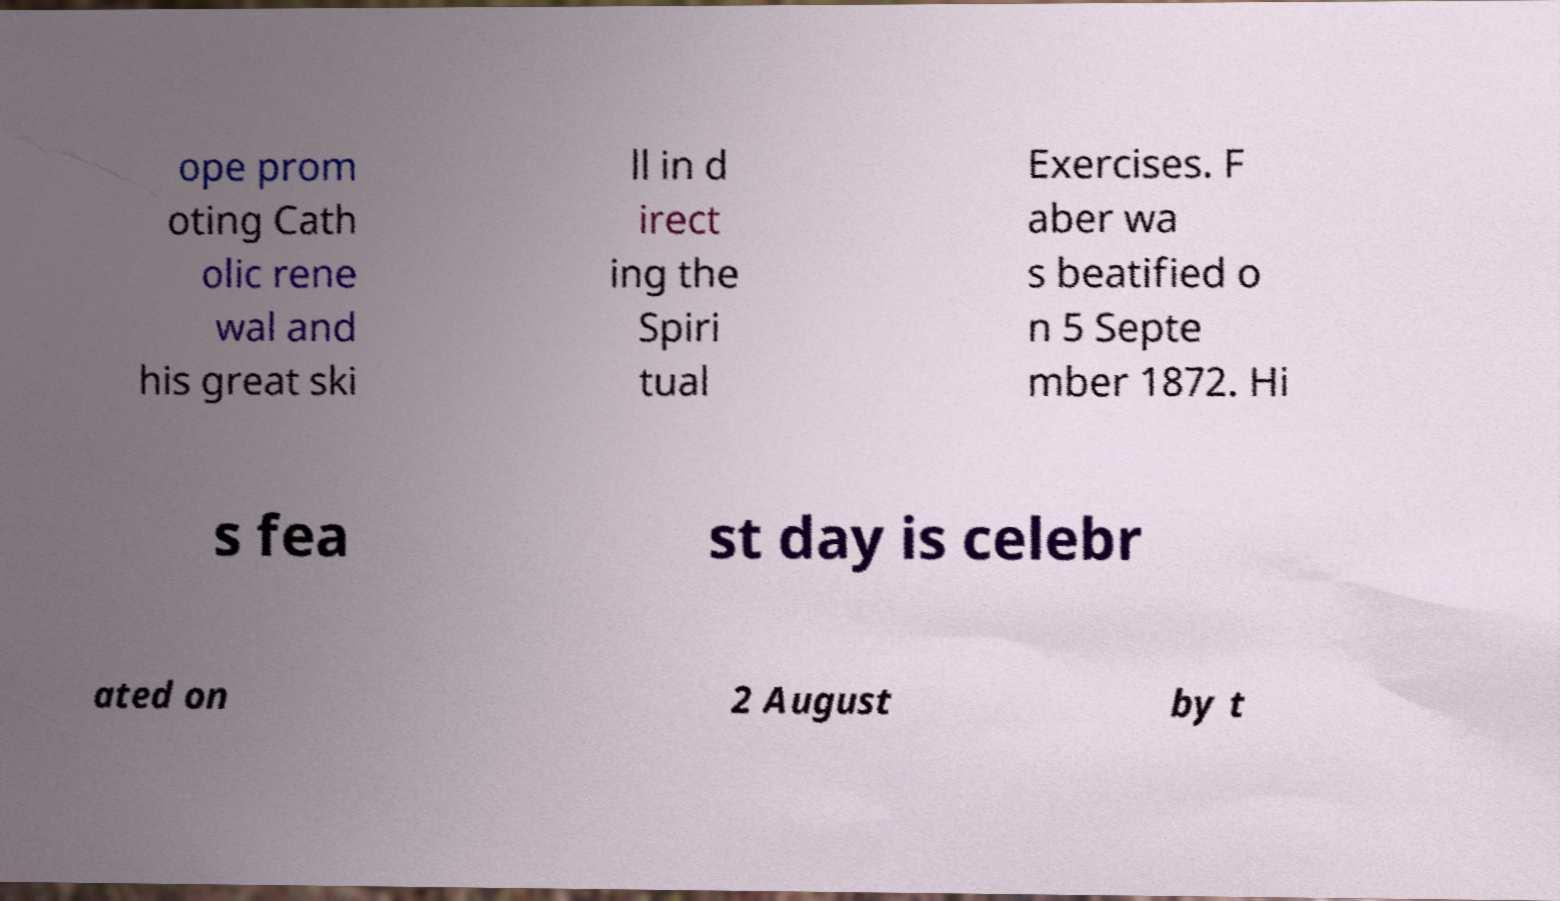I need the written content from this picture converted into text. Can you do that? ope prom oting Cath olic rene wal and his great ski ll in d irect ing the Spiri tual Exercises. F aber wa s beatified o n 5 Septe mber 1872. Hi s fea st day is celebr ated on 2 August by t 